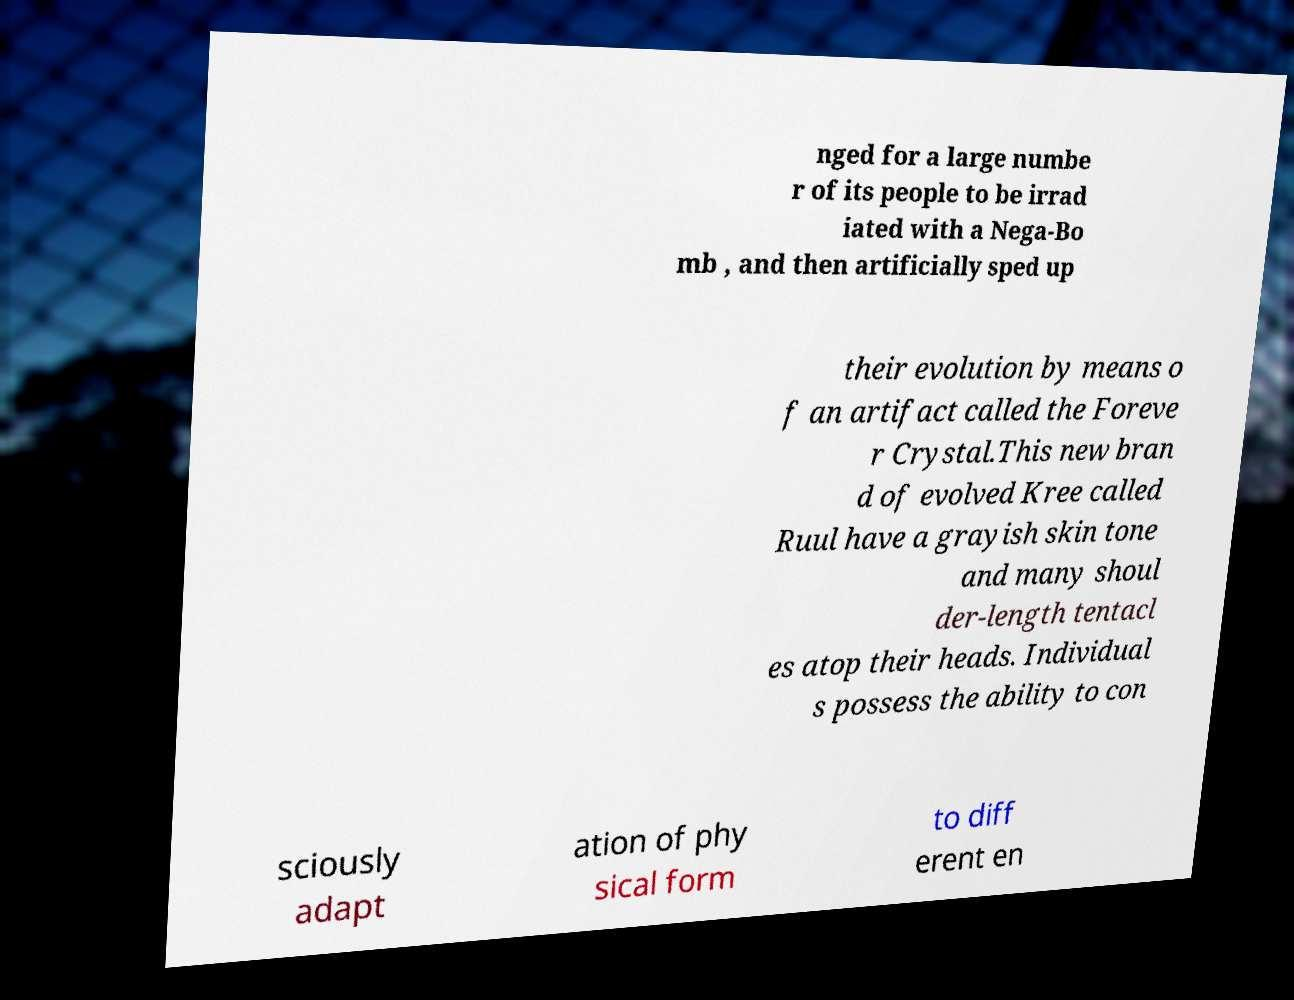For documentation purposes, I need the text within this image transcribed. Could you provide that? nged for a large numbe r of its people to be irrad iated with a Nega-Bo mb , and then artificially sped up their evolution by means o f an artifact called the Foreve r Crystal.This new bran d of evolved Kree called Ruul have a grayish skin tone and many shoul der-length tentacl es atop their heads. Individual s possess the ability to con sciously adapt ation of phy sical form to diff erent en 